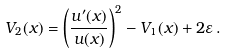Convert formula to latex. <formula><loc_0><loc_0><loc_500><loc_500>V _ { 2 } ( x ) = \left ( \frac { u ^ { \prime } ( x ) } { u ( x ) } \right ) ^ { 2 } - V _ { 1 } ( x ) + 2 \varepsilon \, .</formula> 